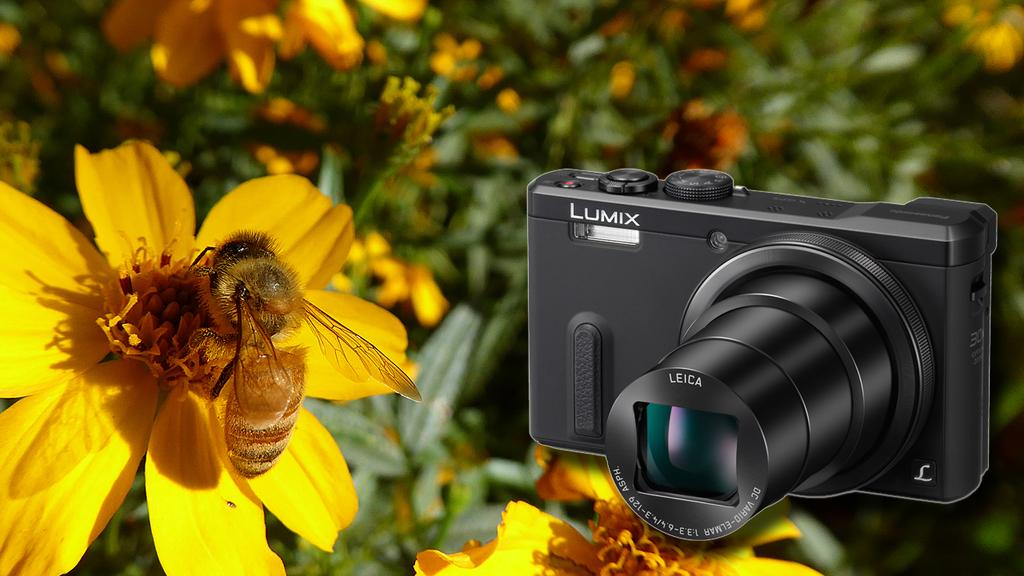What is on the flower in the image? There is an insect on a flower in the image. What object is located near the flower? There is a camera beside the flower. What type of vegetation can be seen on the backside of the image? There are plants with flowers visible on the backside of the image. What type of development is taking place in the image? There is no development project or activity depicted in the image; it features an insect on a flower and a camera beside it. Can you see a guitar in the image? No, there is no guitar present in the image. 